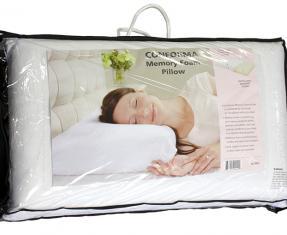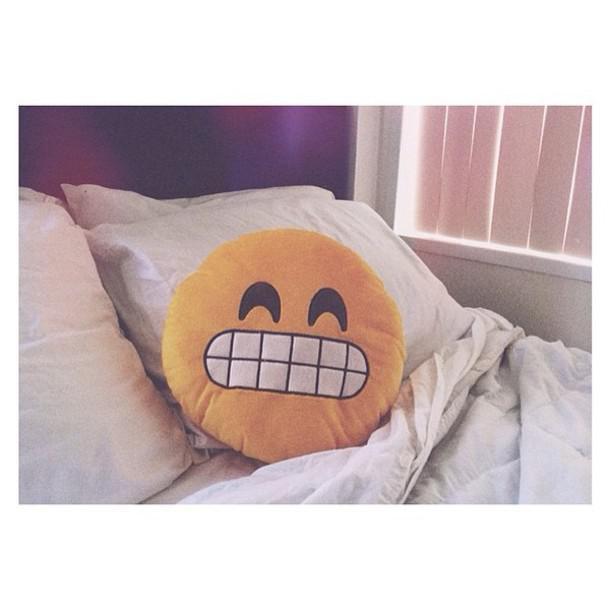The first image is the image on the left, the second image is the image on the right. Considering the images on both sides, is "We see one pillow in the image on the right." valid? Answer yes or no. No. 